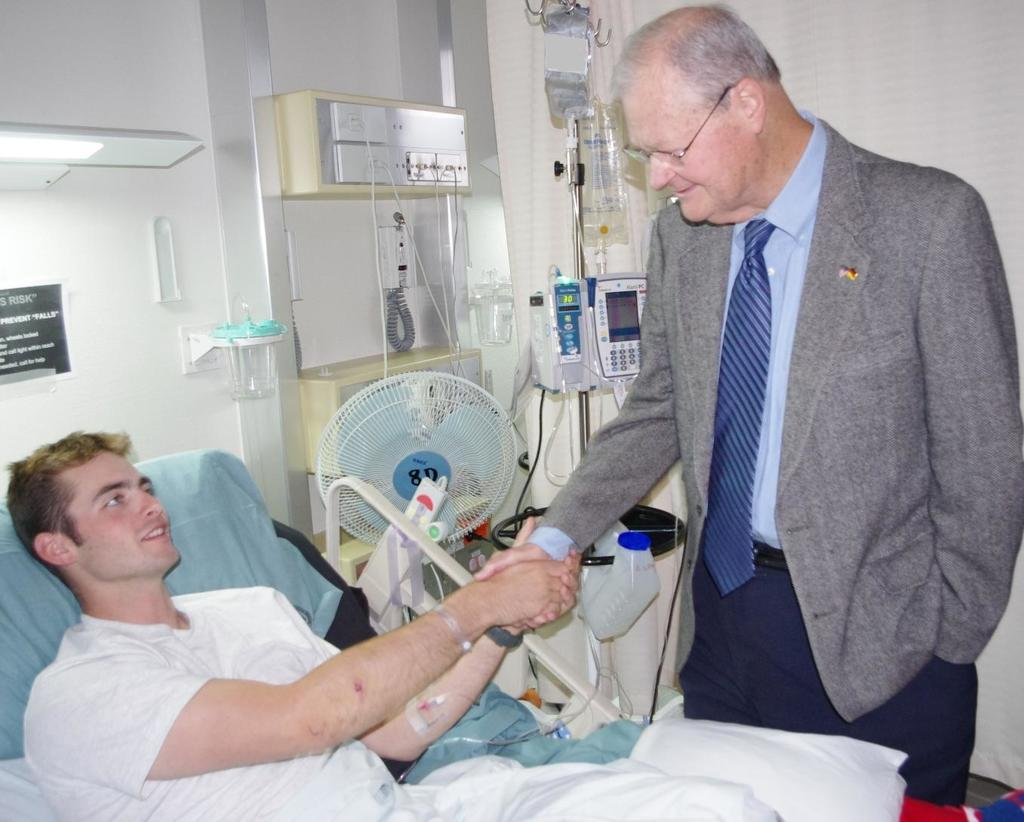What is the person on the bed doing in the image? There is a person on the bed in the image, but their activity is not specified. Who is the man interacting with in the image? The man is shaking hands with someone in the image. What type of environment is suggested by the presence of hospital objects? The presence of hospital objects suggests that the image is set in a medical or healthcare environment. What is the background of the image composed of? There is a wall in the image, which serves as the background. What type of lettuce is being used for digestion in the image? There is no lettuce or digestion-related activity present in the image. 